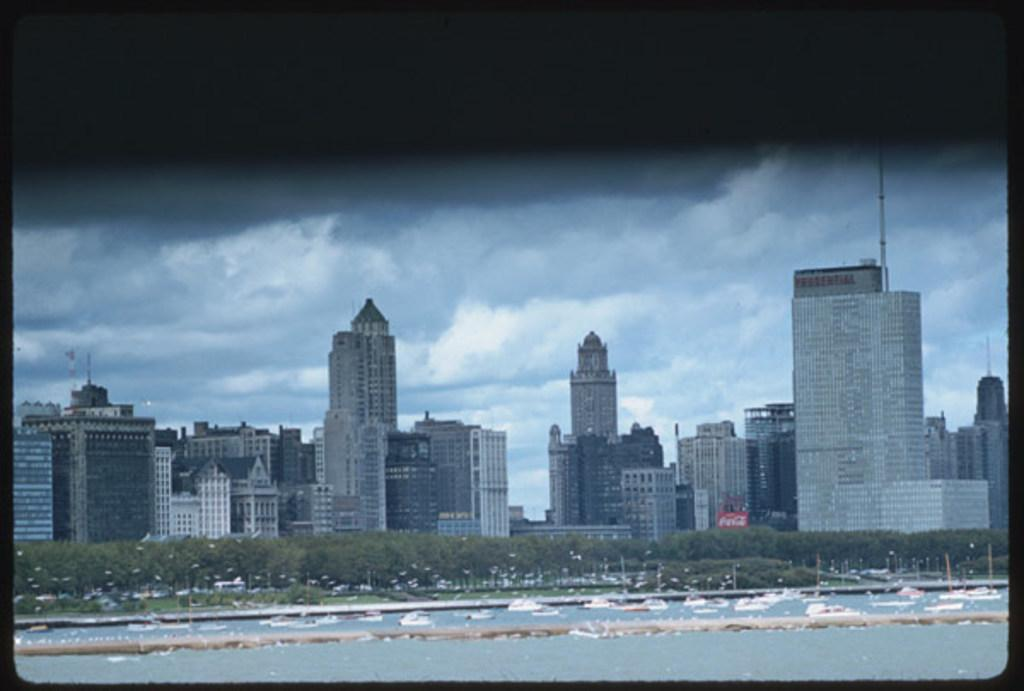What types of structures can be seen in the image? There are many buildings in the image. What natural elements are present in the image? There are trees and plants in the image. What man-made objects can be seen in the image? There are poles, vehicles, and boats in the image. What is the condition of the sky in the background of the image? The background of the image includes a cloudy sky. What is the color of the top of the image? The top of the image appears to be black in color. Reasoning: Let'ing: Let's think step by step in order to produce the conversation. We start by identifying the main subjects and objects in the image based on the provided facts. We then formulate questions that focus on the location and characteristics of these subjects and objects, ensuring that each question can be answered definitively with the information given. We avoid yes/no questions and ensure that the language is simple and clear. Absurd Question/Answer: How many boots are visible in the image? There are no boots present in the image. What are the boys doing in the image? There are no boys present in the image. What role does the grandfather play in the image? There is no grandfather present in the image. How many boots are visible in the image? There are no boots present in the image. What are the boys doing in the image? There are no boys present in the image. What role does the grandfather play in the image? There is no grandfather present in the image. 